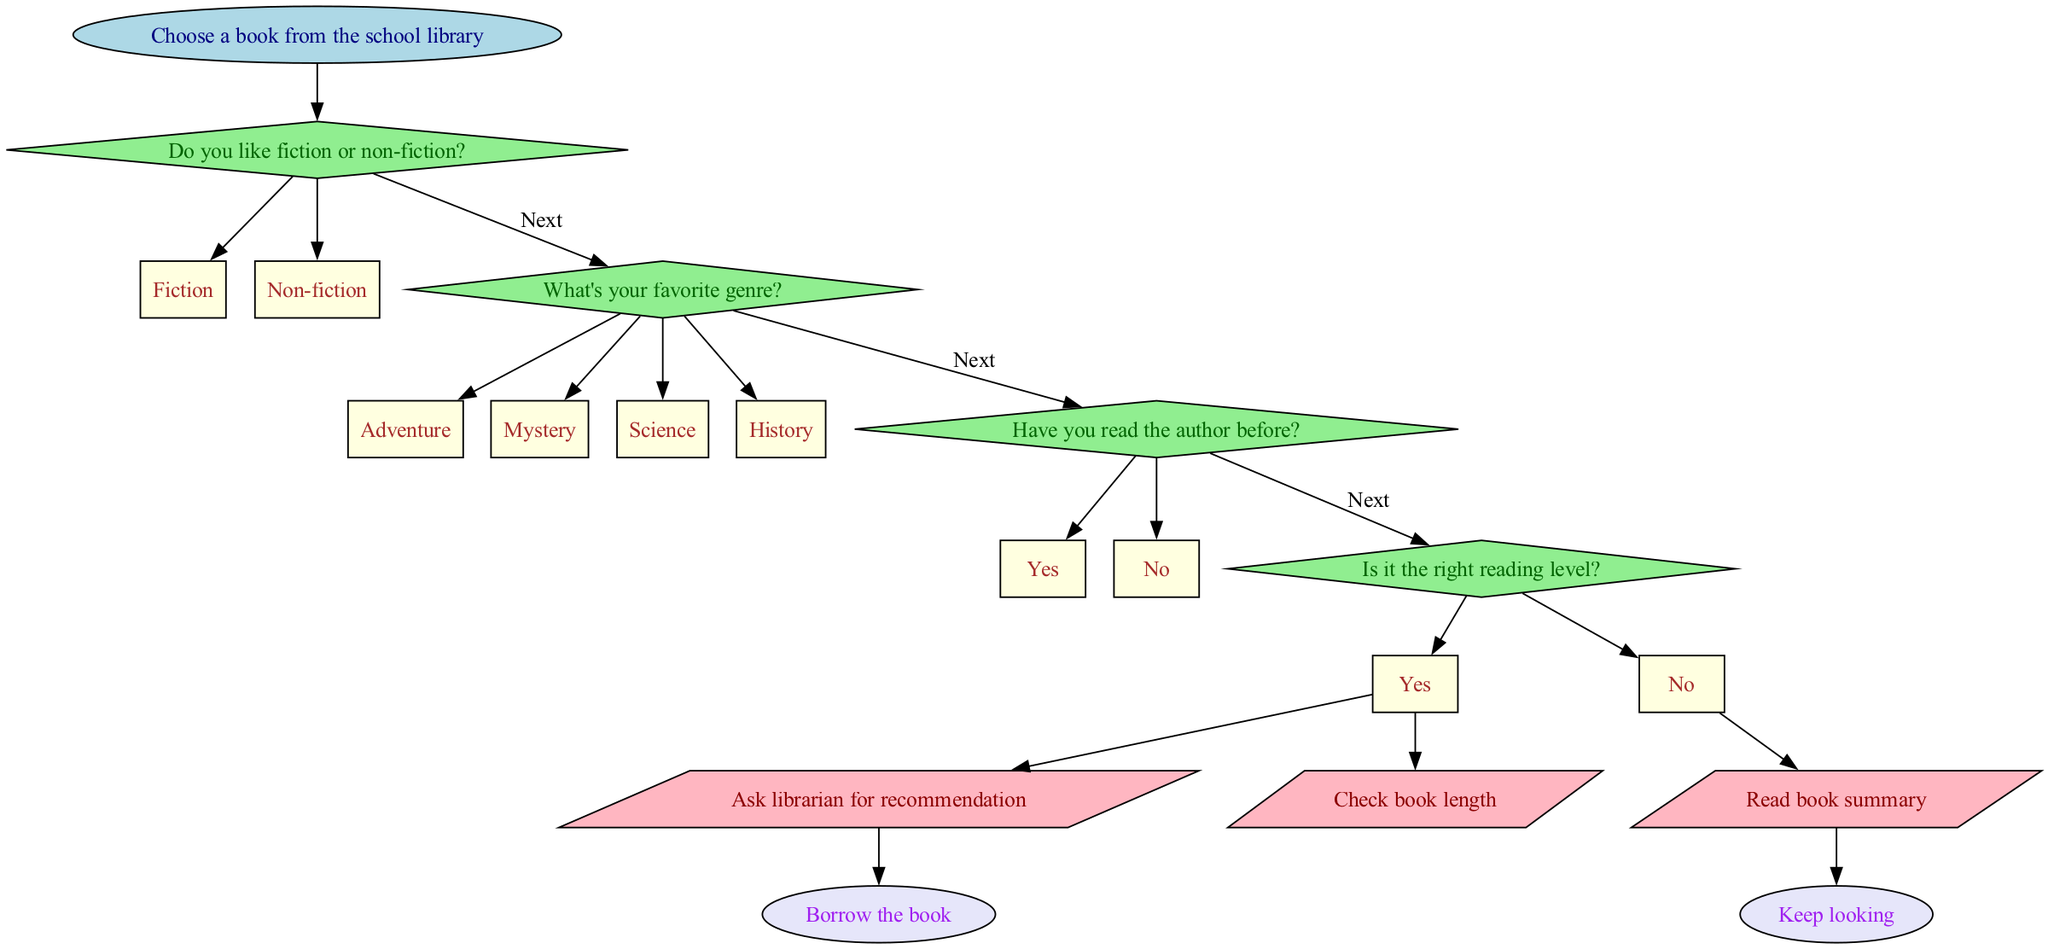What is the starting point of the flowchart? The flowchart begins with the node labeled "Choose a book from the school library," which is the first step in the process.
Answer: Choose a book from the school library What are the options after the first decision? The first decision asks if someone likes "Fiction" or "Non-fiction," so these are the two pathways that follow this decision.
Answer: Fiction, Non-fiction How many action nodes are present in the flowchart? There are three action nodes that represent actions to be taken based on the decisions made in the flowchart.
Answer: 3 What will happen if the answer to "Have you read the author before?" is "No"? If the answer is "No," the flowchart leads to the action node where one must read the book summary, as indicated by the edge connected to that option.
Answer: Read book summary Which action follows if the last decision is "Yes"? If the last decision regarding the reading level is "Yes," it leads to an action that checks the book length, indicated by the edge connecting that option to the respective action node.
Answer: Check book length What nodes connect to the action “Ask librarian for recommendation”? This action node connects from the option "No" related to the decision about having read the author before, indicating that further steps are taken based on that response.
Answer: No (Have you read the author before?) What is the final output of the flowchart? The flowchart ends with two possible outcomes: either "Borrow the book" or "Keep looking," which show the final results of the decision process.
Answer: Borrow the book, Keep looking What follows if someone chooses "Adventure" in the second decision? Choosing "Adventure" leads to the action nodes, as it will navigate towards actions based on the genre selected and proceed to the next steps.
Answer: Action nodes How many decisions are made in the flowchart? There are four decision nodes presented in the flowchart, each guiding the reader toward different outcomes based on their preferences.
Answer: 4 